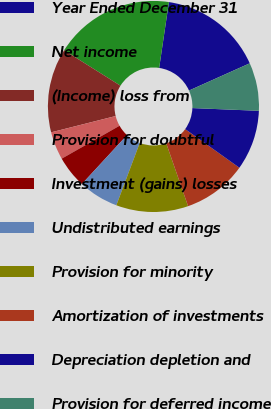<chart> <loc_0><loc_0><loc_500><loc_500><pie_chart><fcel>Year Ended December 31<fcel>Net income<fcel>(Income) loss from<fcel>Provision for doubtful<fcel>Investment (gains) losses<fcel>Undistributed earnings<fcel>Provision for minority<fcel>Amortization of investments<fcel>Depreciation depletion and<fcel>Provision for deferred income<nl><fcel>15.95%<fcel>18.4%<fcel>12.88%<fcel>4.29%<fcel>4.91%<fcel>6.14%<fcel>11.04%<fcel>9.82%<fcel>9.2%<fcel>7.36%<nl></chart> 